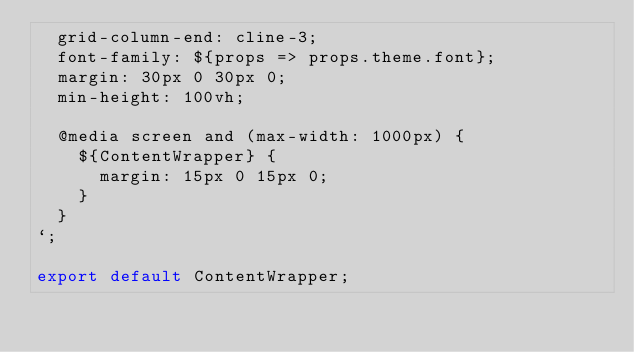<code> <loc_0><loc_0><loc_500><loc_500><_JavaScript_>  grid-column-end: cline-3;
  font-family: ${props => props.theme.font};
  margin: 30px 0 30px 0;
  min-height: 100vh;
  
  @media screen and (max-width: 1000px) {
    ${ContentWrapper} {
      margin: 15px 0 15px 0;
    }
  }
`;

export default ContentWrapper;
</code> 